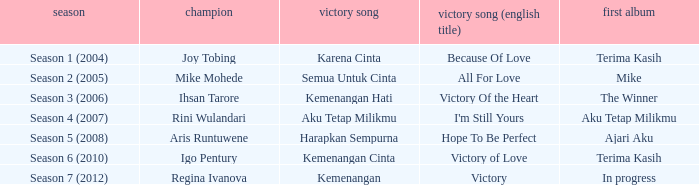Who won with the song kemenangan cinta? Igo Pentury. 